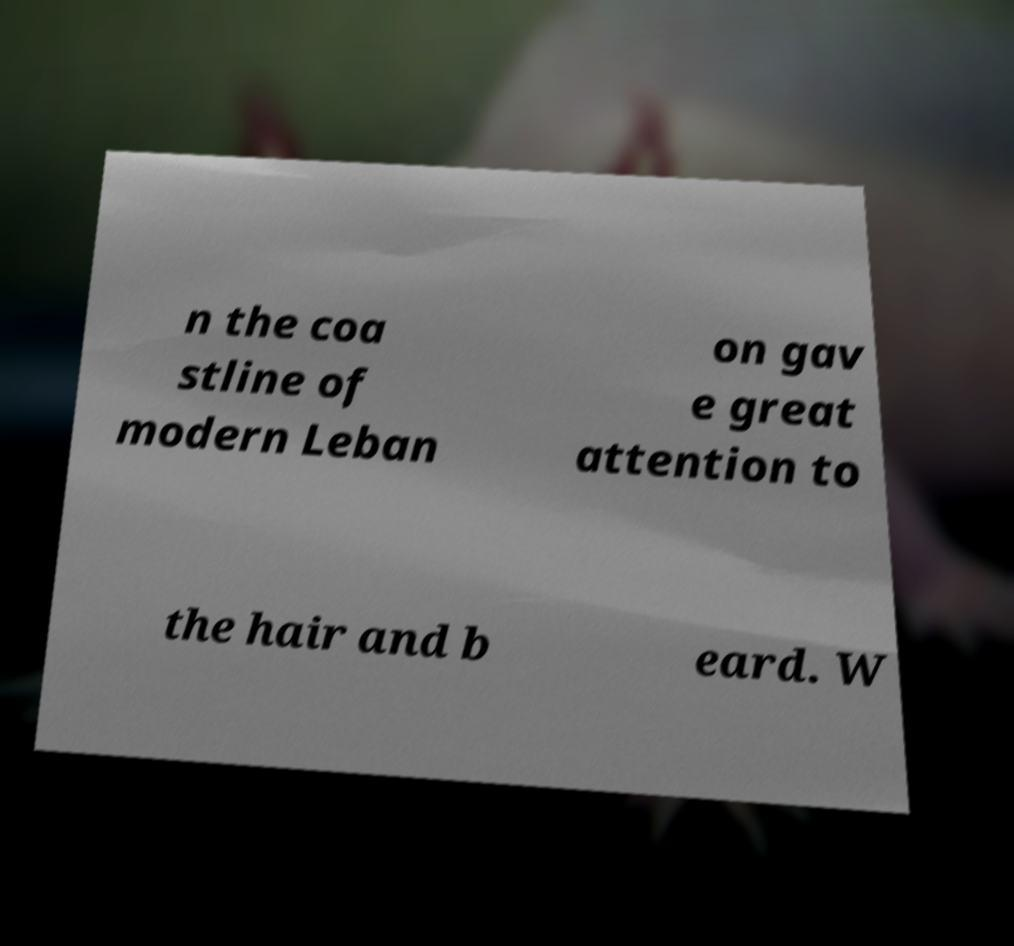Can you read and provide the text displayed in the image?This photo seems to have some interesting text. Can you extract and type it out for me? n the coa stline of modern Leban on gav e great attention to the hair and b eard. W 